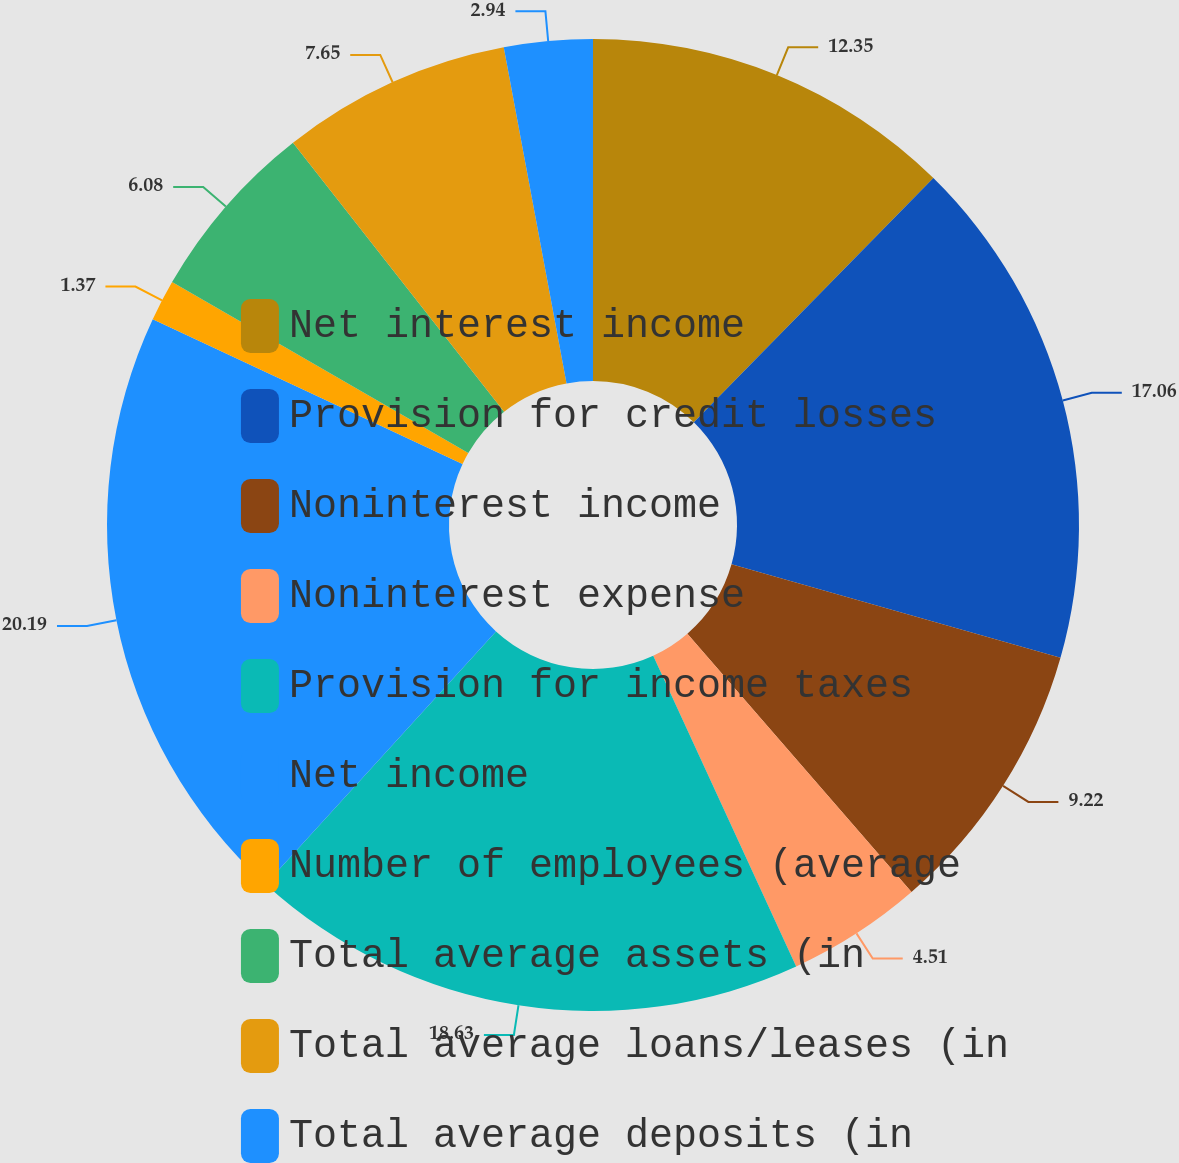Convert chart. <chart><loc_0><loc_0><loc_500><loc_500><pie_chart><fcel>Net interest income<fcel>Provision for credit losses<fcel>Noninterest income<fcel>Noninterest expense<fcel>Provision for income taxes<fcel>Net income<fcel>Number of employees (average<fcel>Total average assets (in<fcel>Total average loans/leases (in<fcel>Total average deposits (in<nl><fcel>12.35%<fcel>17.06%<fcel>9.22%<fcel>4.51%<fcel>18.63%<fcel>20.2%<fcel>1.37%<fcel>6.08%<fcel>7.65%<fcel>2.94%<nl></chart> 